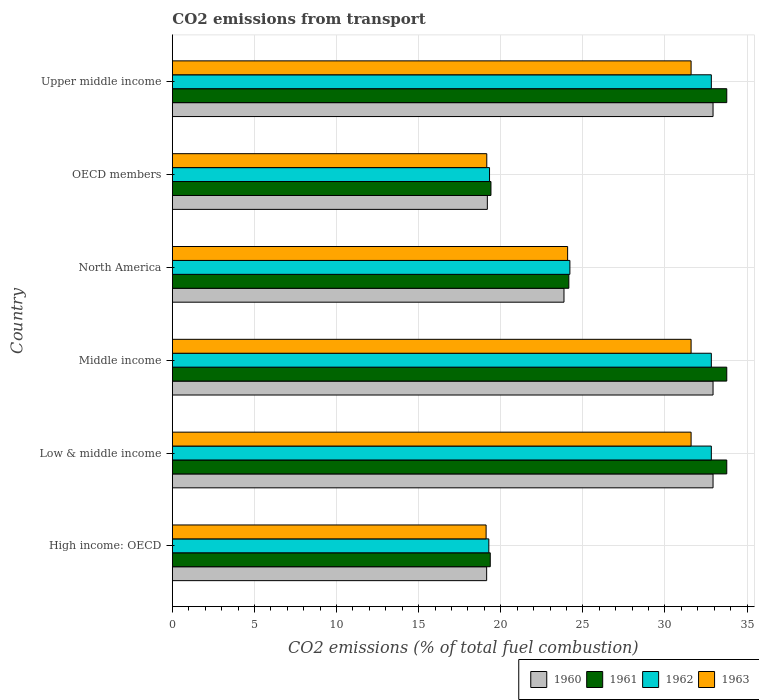How many different coloured bars are there?
Your response must be concise. 4. Are the number of bars per tick equal to the number of legend labels?
Your response must be concise. Yes. How many bars are there on the 2nd tick from the top?
Offer a terse response. 4. What is the label of the 2nd group of bars from the top?
Your answer should be very brief. OECD members. What is the total CO2 emitted in 1963 in North America?
Keep it short and to the point. 24.07. Across all countries, what is the maximum total CO2 emitted in 1963?
Offer a terse response. 31.59. Across all countries, what is the minimum total CO2 emitted in 1961?
Keep it short and to the point. 19.36. In which country was the total CO2 emitted in 1960 minimum?
Your answer should be very brief. High income: OECD. What is the total total CO2 emitted in 1962 in the graph?
Provide a short and direct response. 161.27. What is the difference between the total CO2 emitted in 1960 in North America and that in OECD members?
Ensure brevity in your answer.  4.67. What is the difference between the total CO2 emitted in 1961 in OECD members and the total CO2 emitted in 1963 in Upper middle income?
Keep it short and to the point. -12.19. What is the average total CO2 emitted in 1963 per country?
Give a very brief answer. 26.18. What is the difference between the total CO2 emitted in 1962 and total CO2 emitted in 1963 in Middle income?
Offer a terse response. 1.23. What is the ratio of the total CO2 emitted in 1963 in OECD members to that in Upper middle income?
Give a very brief answer. 0.61. Is the total CO2 emitted in 1962 in Low & middle income less than that in OECD members?
Give a very brief answer. No. What is the difference between the highest and the lowest total CO2 emitted in 1963?
Offer a very short reply. 12.48. How many bars are there?
Give a very brief answer. 24. How many countries are there in the graph?
Your answer should be compact. 6. What is the difference between two consecutive major ticks on the X-axis?
Offer a very short reply. 5. Are the values on the major ticks of X-axis written in scientific E-notation?
Offer a very short reply. No. Does the graph contain grids?
Your answer should be very brief. Yes. What is the title of the graph?
Make the answer very short. CO2 emissions from transport. What is the label or title of the X-axis?
Keep it short and to the point. CO2 emissions (% of total fuel combustion). What is the CO2 emissions (% of total fuel combustion) of 1960 in High income: OECD?
Offer a very short reply. 19.14. What is the CO2 emissions (% of total fuel combustion) of 1961 in High income: OECD?
Your response must be concise. 19.36. What is the CO2 emissions (% of total fuel combustion) of 1962 in High income: OECD?
Provide a succinct answer. 19.27. What is the CO2 emissions (% of total fuel combustion) in 1963 in High income: OECD?
Provide a short and direct response. 19.11. What is the CO2 emissions (% of total fuel combustion) of 1960 in Low & middle income?
Give a very brief answer. 32.93. What is the CO2 emissions (% of total fuel combustion) in 1961 in Low & middle income?
Keep it short and to the point. 33.76. What is the CO2 emissions (% of total fuel combustion) of 1962 in Low & middle income?
Give a very brief answer. 32.82. What is the CO2 emissions (% of total fuel combustion) in 1963 in Low & middle income?
Provide a short and direct response. 31.59. What is the CO2 emissions (% of total fuel combustion) in 1960 in Middle income?
Provide a succinct answer. 32.93. What is the CO2 emissions (% of total fuel combustion) of 1961 in Middle income?
Offer a very short reply. 33.76. What is the CO2 emissions (% of total fuel combustion) of 1962 in Middle income?
Provide a succinct answer. 32.82. What is the CO2 emissions (% of total fuel combustion) in 1963 in Middle income?
Your answer should be compact. 31.59. What is the CO2 emissions (% of total fuel combustion) of 1960 in North America?
Offer a very short reply. 23.85. What is the CO2 emissions (% of total fuel combustion) of 1961 in North America?
Ensure brevity in your answer.  24.15. What is the CO2 emissions (% of total fuel combustion) in 1962 in North America?
Ensure brevity in your answer.  24.21. What is the CO2 emissions (% of total fuel combustion) in 1963 in North America?
Offer a very short reply. 24.07. What is the CO2 emissions (% of total fuel combustion) of 1960 in OECD members?
Offer a terse response. 19.18. What is the CO2 emissions (% of total fuel combustion) in 1961 in OECD members?
Give a very brief answer. 19.4. What is the CO2 emissions (% of total fuel combustion) in 1962 in OECD members?
Your answer should be very brief. 19.32. What is the CO2 emissions (% of total fuel combustion) of 1963 in OECD members?
Provide a succinct answer. 19.15. What is the CO2 emissions (% of total fuel combustion) in 1960 in Upper middle income?
Make the answer very short. 32.93. What is the CO2 emissions (% of total fuel combustion) in 1961 in Upper middle income?
Keep it short and to the point. 33.76. What is the CO2 emissions (% of total fuel combustion) in 1962 in Upper middle income?
Your answer should be compact. 32.82. What is the CO2 emissions (% of total fuel combustion) in 1963 in Upper middle income?
Ensure brevity in your answer.  31.59. Across all countries, what is the maximum CO2 emissions (% of total fuel combustion) of 1960?
Ensure brevity in your answer.  32.93. Across all countries, what is the maximum CO2 emissions (% of total fuel combustion) of 1961?
Offer a terse response. 33.76. Across all countries, what is the maximum CO2 emissions (% of total fuel combustion) in 1962?
Provide a succinct answer. 32.82. Across all countries, what is the maximum CO2 emissions (% of total fuel combustion) of 1963?
Ensure brevity in your answer.  31.59. Across all countries, what is the minimum CO2 emissions (% of total fuel combustion) in 1960?
Your response must be concise. 19.14. Across all countries, what is the minimum CO2 emissions (% of total fuel combustion) in 1961?
Your answer should be compact. 19.36. Across all countries, what is the minimum CO2 emissions (% of total fuel combustion) of 1962?
Offer a very short reply. 19.27. Across all countries, what is the minimum CO2 emissions (% of total fuel combustion) of 1963?
Your answer should be compact. 19.11. What is the total CO2 emissions (% of total fuel combustion) of 1960 in the graph?
Ensure brevity in your answer.  160.96. What is the total CO2 emissions (% of total fuel combustion) in 1961 in the graph?
Your answer should be very brief. 164.2. What is the total CO2 emissions (% of total fuel combustion) in 1962 in the graph?
Ensure brevity in your answer.  161.27. What is the total CO2 emissions (% of total fuel combustion) in 1963 in the graph?
Provide a succinct answer. 157.1. What is the difference between the CO2 emissions (% of total fuel combustion) in 1960 in High income: OECD and that in Low & middle income?
Make the answer very short. -13.79. What is the difference between the CO2 emissions (% of total fuel combustion) in 1961 in High income: OECD and that in Low & middle income?
Ensure brevity in your answer.  -14.4. What is the difference between the CO2 emissions (% of total fuel combustion) in 1962 in High income: OECD and that in Low & middle income?
Give a very brief answer. -13.55. What is the difference between the CO2 emissions (% of total fuel combustion) in 1963 in High income: OECD and that in Low & middle income?
Keep it short and to the point. -12.48. What is the difference between the CO2 emissions (% of total fuel combustion) of 1960 in High income: OECD and that in Middle income?
Provide a succinct answer. -13.79. What is the difference between the CO2 emissions (% of total fuel combustion) of 1961 in High income: OECD and that in Middle income?
Provide a succinct answer. -14.4. What is the difference between the CO2 emissions (% of total fuel combustion) of 1962 in High income: OECD and that in Middle income?
Keep it short and to the point. -13.55. What is the difference between the CO2 emissions (% of total fuel combustion) of 1963 in High income: OECD and that in Middle income?
Make the answer very short. -12.48. What is the difference between the CO2 emissions (% of total fuel combustion) of 1960 in High income: OECD and that in North America?
Make the answer very short. -4.71. What is the difference between the CO2 emissions (% of total fuel combustion) of 1961 in High income: OECD and that in North America?
Offer a terse response. -4.79. What is the difference between the CO2 emissions (% of total fuel combustion) in 1962 in High income: OECD and that in North America?
Offer a very short reply. -4.94. What is the difference between the CO2 emissions (% of total fuel combustion) of 1963 in High income: OECD and that in North America?
Provide a succinct answer. -4.96. What is the difference between the CO2 emissions (% of total fuel combustion) of 1960 in High income: OECD and that in OECD members?
Offer a very short reply. -0.04. What is the difference between the CO2 emissions (% of total fuel combustion) of 1961 in High income: OECD and that in OECD members?
Your response must be concise. -0.04. What is the difference between the CO2 emissions (% of total fuel combustion) in 1962 in High income: OECD and that in OECD members?
Your answer should be compact. -0.04. What is the difference between the CO2 emissions (% of total fuel combustion) in 1963 in High income: OECD and that in OECD members?
Your answer should be compact. -0.04. What is the difference between the CO2 emissions (% of total fuel combustion) of 1960 in High income: OECD and that in Upper middle income?
Your response must be concise. -13.79. What is the difference between the CO2 emissions (% of total fuel combustion) in 1961 in High income: OECD and that in Upper middle income?
Offer a terse response. -14.4. What is the difference between the CO2 emissions (% of total fuel combustion) in 1962 in High income: OECD and that in Upper middle income?
Give a very brief answer. -13.55. What is the difference between the CO2 emissions (% of total fuel combustion) in 1963 in High income: OECD and that in Upper middle income?
Your answer should be compact. -12.48. What is the difference between the CO2 emissions (% of total fuel combustion) in 1962 in Low & middle income and that in Middle income?
Provide a short and direct response. 0. What is the difference between the CO2 emissions (% of total fuel combustion) of 1960 in Low & middle income and that in North America?
Offer a very short reply. 9.08. What is the difference between the CO2 emissions (% of total fuel combustion) in 1961 in Low & middle income and that in North America?
Provide a short and direct response. 9.62. What is the difference between the CO2 emissions (% of total fuel combustion) of 1962 in Low & middle income and that in North America?
Ensure brevity in your answer.  8.61. What is the difference between the CO2 emissions (% of total fuel combustion) in 1963 in Low & middle income and that in North America?
Provide a succinct answer. 7.52. What is the difference between the CO2 emissions (% of total fuel combustion) of 1960 in Low & middle income and that in OECD members?
Your response must be concise. 13.75. What is the difference between the CO2 emissions (% of total fuel combustion) in 1961 in Low & middle income and that in OECD members?
Ensure brevity in your answer.  14.36. What is the difference between the CO2 emissions (% of total fuel combustion) in 1962 in Low & middle income and that in OECD members?
Provide a short and direct response. 13.51. What is the difference between the CO2 emissions (% of total fuel combustion) in 1963 in Low & middle income and that in OECD members?
Offer a terse response. 12.44. What is the difference between the CO2 emissions (% of total fuel combustion) of 1960 in Low & middle income and that in Upper middle income?
Your answer should be very brief. 0. What is the difference between the CO2 emissions (% of total fuel combustion) of 1961 in Low & middle income and that in Upper middle income?
Keep it short and to the point. 0. What is the difference between the CO2 emissions (% of total fuel combustion) of 1963 in Low & middle income and that in Upper middle income?
Your answer should be very brief. 0. What is the difference between the CO2 emissions (% of total fuel combustion) in 1960 in Middle income and that in North America?
Give a very brief answer. 9.08. What is the difference between the CO2 emissions (% of total fuel combustion) of 1961 in Middle income and that in North America?
Provide a succinct answer. 9.62. What is the difference between the CO2 emissions (% of total fuel combustion) of 1962 in Middle income and that in North America?
Provide a short and direct response. 8.61. What is the difference between the CO2 emissions (% of total fuel combustion) of 1963 in Middle income and that in North America?
Your answer should be very brief. 7.52. What is the difference between the CO2 emissions (% of total fuel combustion) of 1960 in Middle income and that in OECD members?
Provide a short and direct response. 13.75. What is the difference between the CO2 emissions (% of total fuel combustion) in 1961 in Middle income and that in OECD members?
Offer a terse response. 14.36. What is the difference between the CO2 emissions (% of total fuel combustion) in 1962 in Middle income and that in OECD members?
Your answer should be very brief. 13.51. What is the difference between the CO2 emissions (% of total fuel combustion) in 1963 in Middle income and that in OECD members?
Give a very brief answer. 12.44. What is the difference between the CO2 emissions (% of total fuel combustion) in 1960 in Middle income and that in Upper middle income?
Provide a succinct answer. 0. What is the difference between the CO2 emissions (% of total fuel combustion) of 1961 in Middle income and that in Upper middle income?
Make the answer very short. 0. What is the difference between the CO2 emissions (% of total fuel combustion) in 1960 in North America and that in OECD members?
Give a very brief answer. 4.67. What is the difference between the CO2 emissions (% of total fuel combustion) of 1961 in North America and that in OECD members?
Offer a very short reply. 4.74. What is the difference between the CO2 emissions (% of total fuel combustion) in 1962 in North America and that in OECD members?
Give a very brief answer. 4.89. What is the difference between the CO2 emissions (% of total fuel combustion) of 1963 in North America and that in OECD members?
Provide a succinct answer. 4.92. What is the difference between the CO2 emissions (% of total fuel combustion) in 1960 in North America and that in Upper middle income?
Give a very brief answer. -9.08. What is the difference between the CO2 emissions (% of total fuel combustion) in 1961 in North America and that in Upper middle income?
Offer a very short reply. -9.62. What is the difference between the CO2 emissions (% of total fuel combustion) in 1962 in North America and that in Upper middle income?
Make the answer very short. -8.61. What is the difference between the CO2 emissions (% of total fuel combustion) of 1963 in North America and that in Upper middle income?
Ensure brevity in your answer.  -7.52. What is the difference between the CO2 emissions (% of total fuel combustion) of 1960 in OECD members and that in Upper middle income?
Provide a succinct answer. -13.75. What is the difference between the CO2 emissions (% of total fuel combustion) in 1961 in OECD members and that in Upper middle income?
Provide a short and direct response. -14.36. What is the difference between the CO2 emissions (% of total fuel combustion) in 1962 in OECD members and that in Upper middle income?
Make the answer very short. -13.51. What is the difference between the CO2 emissions (% of total fuel combustion) in 1963 in OECD members and that in Upper middle income?
Make the answer very short. -12.44. What is the difference between the CO2 emissions (% of total fuel combustion) in 1960 in High income: OECD and the CO2 emissions (% of total fuel combustion) in 1961 in Low & middle income?
Make the answer very short. -14.62. What is the difference between the CO2 emissions (% of total fuel combustion) of 1960 in High income: OECD and the CO2 emissions (% of total fuel combustion) of 1962 in Low & middle income?
Provide a succinct answer. -13.68. What is the difference between the CO2 emissions (% of total fuel combustion) in 1960 in High income: OECD and the CO2 emissions (% of total fuel combustion) in 1963 in Low & middle income?
Keep it short and to the point. -12.45. What is the difference between the CO2 emissions (% of total fuel combustion) in 1961 in High income: OECD and the CO2 emissions (% of total fuel combustion) in 1962 in Low & middle income?
Provide a short and direct response. -13.46. What is the difference between the CO2 emissions (% of total fuel combustion) in 1961 in High income: OECD and the CO2 emissions (% of total fuel combustion) in 1963 in Low & middle income?
Ensure brevity in your answer.  -12.23. What is the difference between the CO2 emissions (% of total fuel combustion) of 1962 in High income: OECD and the CO2 emissions (% of total fuel combustion) of 1963 in Low & middle income?
Offer a terse response. -12.32. What is the difference between the CO2 emissions (% of total fuel combustion) of 1960 in High income: OECD and the CO2 emissions (% of total fuel combustion) of 1961 in Middle income?
Offer a very short reply. -14.62. What is the difference between the CO2 emissions (% of total fuel combustion) of 1960 in High income: OECD and the CO2 emissions (% of total fuel combustion) of 1962 in Middle income?
Your answer should be very brief. -13.68. What is the difference between the CO2 emissions (% of total fuel combustion) of 1960 in High income: OECD and the CO2 emissions (% of total fuel combustion) of 1963 in Middle income?
Your response must be concise. -12.45. What is the difference between the CO2 emissions (% of total fuel combustion) of 1961 in High income: OECD and the CO2 emissions (% of total fuel combustion) of 1962 in Middle income?
Provide a succinct answer. -13.46. What is the difference between the CO2 emissions (% of total fuel combustion) in 1961 in High income: OECD and the CO2 emissions (% of total fuel combustion) in 1963 in Middle income?
Ensure brevity in your answer.  -12.23. What is the difference between the CO2 emissions (% of total fuel combustion) of 1962 in High income: OECD and the CO2 emissions (% of total fuel combustion) of 1963 in Middle income?
Ensure brevity in your answer.  -12.32. What is the difference between the CO2 emissions (% of total fuel combustion) of 1960 in High income: OECD and the CO2 emissions (% of total fuel combustion) of 1961 in North America?
Offer a very short reply. -5.01. What is the difference between the CO2 emissions (% of total fuel combustion) in 1960 in High income: OECD and the CO2 emissions (% of total fuel combustion) in 1962 in North America?
Your response must be concise. -5.07. What is the difference between the CO2 emissions (% of total fuel combustion) in 1960 in High income: OECD and the CO2 emissions (% of total fuel combustion) in 1963 in North America?
Your answer should be very brief. -4.93. What is the difference between the CO2 emissions (% of total fuel combustion) of 1961 in High income: OECD and the CO2 emissions (% of total fuel combustion) of 1962 in North America?
Your answer should be very brief. -4.85. What is the difference between the CO2 emissions (% of total fuel combustion) in 1961 in High income: OECD and the CO2 emissions (% of total fuel combustion) in 1963 in North America?
Make the answer very short. -4.71. What is the difference between the CO2 emissions (% of total fuel combustion) in 1962 in High income: OECD and the CO2 emissions (% of total fuel combustion) in 1963 in North America?
Your answer should be very brief. -4.8. What is the difference between the CO2 emissions (% of total fuel combustion) of 1960 in High income: OECD and the CO2 emissions (% of total fuel combustion) of 1961 in OECD members?
Your response must be concise. -0.26. What is the difference between the CO2 emissions (% of total fuel combustion) in 1960 in High income: OECD and the CO2 emissions (% of total fuel combustion) in 1962 in OECD members?
Your answer should be very brief. -0.18. What is the difference between the CO2 emissions (% of total fuel combustion) of 1960 in High income: OECD and the CO2 emissions (% of total fuel combustion) of 1963 in OECD members?
Provide a succinct answer. -0.01. What is the difference between the CO2 emissions (% of total fuel combustion) of 1961 in High income: OECD and the CO2 emissions (% of total fuel combustion) of 1962 in OECD members?
Provide a short and direct response. 0.04. What is the difference between the CO2 emissions (% of total fuel combustion) in 1961 in High income: OECD and the CO2 emissions (% of total fuel combustion) in 1963 in OECD members?
Your answer should be compact. 0.21. What is the difference between the CO2 emissions (% of total fuel combustion) in 1962 in High income: OECD and the CO2 emissions (% of total fuel combustion) in 1963 in OECD members?
Provide a short and direct response. 0.13. What is the difference between the CO2 emissions (% of total fuel combustion) in 1960 in High income: OECD and the CO2 emissions (% of total fuel combustion) in 1961 in Upper middle income?
Keep it short and to the point. -14.62. What is the difference between the CO2 emissions (% of total fuel combustion) of 1960 in High income: OECD and the CO2 emissions (% of total fuel combustion) of 1962 in Upper middle income?
Your answer should be compact. -13.68. What is the difference between the CO2 emissions (% of total fuel combustion) of 1960 in High income: OECD and the CO2 emissions (% of total fuel combustion) of 1963 in Upper middle income?
Keep it short and to the point. -12.45. What is the difference between the CO2 emissions (% of total fuel combustion) in 1961 in High income: OECD and the CO2 emissions (% of total fuel combustion) in 1962 in Upper middle income?
Ensure brevity in your answer.  -13.46. What is the difference between the CO2 emissions (% of total fuel combustion) in 1961 in High income: OECD and the CO2 emissions (% of total fuel combustion) in 1963 in Upper middle income?
Provide a succinct answer. -12.23. What is the difference between the CO2 emissions (% of total fuel combustion) in 1962 in High income: OECD and the CO2 emissions (% of total fuel combustion) in 1963 in Upper middle income?
Give a very brief answer. -12.32. What is the difference between the CO2 emissions (% of total fuel combustion) in 1960 in Low & middle income and the CO2 emissions (% of total fuel combustion) in 1961 in Middle income?
Ensure brevity in your answer.  -0.84. What is the difference between the CO2 emissions (% of total fuel combustion) in 1960 in Low & middle income and the CO2 emissions (% of total fuel combustion) in 1962 in Middle income?
Provide a succinct answer. 0.1. What is the difference between the CO2 emissions (% of total fuel combustion) in 1960 in Low & middle income and the CO2 emissions (% of total fuel combustion) in 1963 in Middle income?
Offer a very short reply. 1.34. What is the difference between the CO2 emissions (% of total fuel combustion) of 1961 in Low & middle income and the CO2 emissions (% of total fuel combustion) of 1962 in Middle income?
Provide a succinct answer. 0.94. What is the difference between the CO2 emissions (% of total fuel combustion) in 1961 in Low & middle income and the CO2 emissions (% of total fuel combustion) in 1963 in Middle income?
Provide a succinct answer. 2.17. What is the difference between the CO2 emissions (% of total fuel combustion) in 1962 in Low & middle income and the CO2 emissions (% of total fuel combustion) in 1963 in Middle income?
Your response must be concise. 1.23. What is the difference between the CO2 emissions (% of total fuel combustion) of 1960 in Low & middle income and the CO2 emissions (% of total fuel combustion) of 1961 in North America?
Ensure brevity in your answer.  8.78. What is the difference between the CO2 emissions (% of total fuel combustion) of 1960 in Low & middle income and the CO2 emissions (% of total fuel combustion) of 1962 in North America?
Your answer should be compact. 8.72. What is the difference between the CO2 emissions (% of total fuel combustion) in 1960 in Low & middle income and the CO2 emissions (% of total fuel combustion) in 1963 in North America?
Make the answer very short. 8.86. What is the difference between the CO2 emissions (% of total fuel combustion) in 1961 in Low & middle income and the CO2 emissions (% of total fuel combustion) in 1962 in North America?
Ensure brevity in your answer.  9.55. What is the difference between the CO2 emissions (% of total fuel combustion) of 1961 in Low & middle income and the CO2 emissions (% of total fuel combustion) of 1963 in North America?
Your response must be concise. 9.69. What is the difference between the CO2 emissions (% of total fuel combustion) in 1962 in Low & middle income and the CO2 emissions (% of total fuel combustion) in 1963 in North America?
Make the answer very short. 8.75. What is the difference between the CO2 emissions (% of total fuel combustion) of 1960 in Low & middle income and the CO2 emissions (% of total fuel combustion) of 1961 in OECD members?
Offer a very short reply. 13.53. What is the difference between the CO2 emissions (% of total fuel combustion) in 1960 in Low & middle income and the CO2 emissions (% of total fuel combustion) in 1962 in OECD members?
Offer a very short reply. 13.61. What is the difference between the CO2 emissions (% of total fuel combustion) of 1960 in Low & middle income and the CO2 emissions (% of total fuel combustion) of 1963 in OECD members?
Ensure brevity in your answer.  13.78. What is the difference between the CO2 emissions (% of total fuel combustion) in 1961 in Low & middle income and the CO2 emissions (% of total fuel combustion) in 1962 in OECD members?
Your answer should be very brief. 14.45. What is the difference between the CO2 emissions (% of total fuel combustion) of 1961 in Low & middle income and the CO2 emissions (% of total fuel combustion) of 1963 in OECD members?
Provide a short and direct response. 14.62. What is the difference between the CO2 emissions (% of total fuel combustion) of 1962 in Low & middle income and the CO2 emissions (% of total fuel combustion) of 1963 in OECD members?
Ensure brevity in your answer.  13.68. What is the difference between the CO2 emissions (% of total fuel combustion) in 1960 in Low & middle income and the CO2 emissions (% of total fuel combustion) in 1961 in Upper middle income?
Make the answer very short. -0.84. What is the difference between the CO2 emissions (% of total fuel combustion) of 1960 in Low & middle income and the CO2 emissions (% of total fuel combustion) of 1962 in Upper middle income?
Your answer should be very brief. 0.1. What is the difference between the CO2 emissions (% of total fuel combustion) of 1960 in Low & middle income and the CO2 emissions (% of total fuel combustion) of 1963 in Upper middle income?
Provide a short and direct response. 1.34. What is the difference between the CO2 emissions (% of total fuel combustion) of 1961 in Low & middle income and the CO2 emissions (% of total fuel combustion) of 1962 in Upper middle income?
Offer a terse response. 0.94. What is the difference between the CO2 emissions (% of total fuel combustion) in 1961 in Low & middle income and the CO2 emissions (% of total fuel combustion) in 1963 in Upper middle income?
Your answer should be compact. 2.17. What is the difference between the CO2 emissions (% of total fuel combustion) of 1962 in Low & middle income and the CO2 emissions (% of total fuel combustion) of 1963 in Upper middle income?
Offer a terse response. 1.23. What is the difference between the CO2 emissions (% of total fuel combustion) in 1960 in Middle income and the CO2 emissions (% of total fuel combustion) in 1961 in North America?
Ensure brevity in your answer.  8.78. What is the difference between the CO2 emissions (% of total fuel combustion) in 1960 in Middle income and the CO2 emissions (% of total fuel combustion) in 1962 in North America?
Make the answer very short. 8.72. What is the difference between the CO2 emissions (% of total fuel combustion) of 1960 in Middle income and the CO2 emissions (% of total fuel combustion) of 1963 in North America?
Keep it short and to the point. 8.86. What is the difference between the CO2 emissions (% of total fuel combustion) of 1961 in Middle income and the CO2 emissions (% of total fuel combustion) of 1962 in North America?
Offer a very short reply. 9.55. What is the difference between the CO2 emissions (% of total fuel combustion) of 1961 in Middle income and the CO2 emissions (% of total fuel combustion) of 1963 in North America?
Offer a very short reply. 9.69. What is the difference between the CO2 emissions (% of total fuel combustion) of 1962 in Middle income and the CO2 emissions (% of total fuel combustion) of 1963 in North America?
Your response must be concise. 8.75. What is the difference between the CO2 emissions (% of total fuel combustion) of 1960 in Middle income and the CO2 emissions (% of total fuel combustion) of 1961 in OECD members?
Your response must be concise. 13.53. What is the difference between the CO2 emissions (% of total fuel combustion) in 1960 in Middle income and the CO2 emissions (% of total fuel combustion) in 1962 in OECD members?
Provide a succinct answer. 13.61. What is the difference between the CO2 emissions (% of total fuel combustion) of 1960 in Middle income and the CO2 emissions (% of total fuel combustion) of 1963 in OECD members?
Your answer should be very brief. 13.78. What is the difference between the CO2 emissions (% of total fuel combustion) of 1961 in Middle income and the CO2 emissions (% of total fuel combustion) of 1962 in OECD members?
Provide a short and direct response. 14.45. What is the difference between the CO2 emissions (% of total fuel combustion) in 1961 in Middle income and the CO2 emissions (% of total fuel combustion) in 1963 in OECD members?
Offer a very short reply. 14.62. What is the difference between the CO2 emissions (% of total fuel combustion) in 1962 in Middle income and the CO2 emissions (% of total fuel combustion) in 1963 in OECD members?
Offer a very short reply. 13.68. What is the difference between the CO2 emissions (% of total fuel combustion) of 1960 in Middle income and the CO2 emissions (% of total fuel combustion) of 1961 in Upper middle income?
Provide a short and direct response. -0.84. What is the difference between the CO2 emissions (% of total fuel combustion) of 1960 in Middle income and the CO2 emissions (% of total fuel combustion) of 1962 in Upper middle income?
Give a very brief answer. 0.1. What is the difference between the CO2 emissions (% of total fuel combustion) of 1960 in Middle income and the CO2 emissions (% of total fuel combustion) of 1963 in Upper middle income?
Provide a short and direct response. 1.34. What is the difference between the CO2 emissions (% of total fuel combustion) of 1961 in Middle income and the CO2 emissions (% of total fuel combustion) of 1962 in Upper middle income?
Make the answer very short. 0.94. What is the difference between the CO2 emissions (% of total fuel combustion) of 1961 in Middle income and the CO2 emissions (% of total fuel combustion) of 1963 in Upper middle income?
Offer a very short reply. 2.17. What is the difference between the CO2 emissions (% of total fuel combustion) in 1962 in Middle income and the CO2 emissions (% of total fuel combustion) in 1963 in Upper middle income?
Your answer should be compact. 1.23. What is the difference between the CO2 emissions (% of total fuel combustion) in 1960 in North America and the CO2 emissions (% of total fuel combustion) in 1961 in OECD members?
Ensure brevity in your answer.  4.45. What is the difference between the CO2 emissions (% of total fuel combustion) of 1960 in North America and the CO2 emissions (% of total fuel combustion) of 1962 in OECD members?
Keep it short and to the point. 4.53. What is the difference between the CO2 emissions (% of total fuel combustion) in 1960 in North America and the CO2 emissions (% of total fuel combustion) in 1963 in OECD members?
Ensure brevity in your answer.  4.7. What is the difference between the CO2 emissions (% of total fuel combustion) in 1961 in North America and the CO2 emissions (% of total fuel combustion) in 1962 in OECD members?
Keep it short and to the point. 4.83. What is the difference between the CO2 emissions (% of total fuel combustion) of 1961 in North America and the CO2 emissions (% of total fuel combustion) of 1963 in OECD members?
Your answer should be very brief. 5. What is the difference between the CO2 emissions (% of total fuel combustion) of 1962 in North America and the CO2 emissions (% of total fuel combustion) of 1963 in OECD members?
Provide a short and direct response. 5.06. What is the difference between the CO2 emissions (% of total fuel combustion) of 1960 in North America and the CO2 emissions (% of total fuel combustion) of 1961 in Upper middle income?
Provide a short and direct response. -9.91. What is the difference between the CO2 emissions (% of total fuel combustion) in 1960 in North America and the CO2 emissions (% of total fuel combustion) in 1962 in Upper middle income?
Your answer should be compact. -8.97. What is the difference between the CO2 emissions (% of total fuel combustion) of 1960 in North America and the CO2 emissions (% of total fuel combustion) of 1963 in Upper middle income?
Your answer should be compact. -7.74. What is the difference between the CO2 emissions (% of total fuel combustion) of 1961 in North America and the CO2 emissions (% of total fuel combustion) of 1962 in Upper middle income?
Provide a succinct answer. -8.68. What is the difference between the CO2 emissions (% of total fuel combustion) in 1961 in North America and the CO2 emissions (% of total fuel combustion) in 1963 in Upper middle income?
Give a very brief answer. -7.45. What is the difference between the CO2 emissions (% of total fuel combustion) of 1962 in North America and the CO2 emissions (% of total fuel combustion) of 1963 in Upper middle income?
Provide a short and direct response. -7.38. What is the difference between the CO2 emissions (% of total fuel combustion) of 1960 in OECD members and the CO2 emissions (% of total fuel combustion) of 1961 in Upper middle income?
Provide a short and direct response. -14.58. What is the difference between the CO2 emissions (% of total fuel combustion) of 1960 in OECD members and the CO2 emissions (% of total fuel combustion) of 1962 in Upper middle income?
Make the answer very short. -13.64. What is the difference between the CO2 emissions (% of total fuel combustion) in 1960 in OECD members and the CO2 emissions (% of total fuel combustion) in 1963 in Upper middle income?
Offer a very short reply. -12.41. What is the difference between the CO2 emissions (% of total fuel combustion) in 1961 in OECD members and the CO2 emissions (% of total fuel combustion) in 1962 in Upper middle income?
Your answer should be very brief. -13.42. What is the difference between the CO2 emissions (% of total fuel combustion) of 1961 in OECD members and the CO2 emissions (% of total fuel combustion) of 1963 in Upper middle income?
Provide a succinct answer. -12.19. What is the difference between the CO2 emissions (% of total fuel combustion) in 1962 in OECD members and the CO2 emissions (% of total fuel combustion) in 1963 in Upper middle income?
Offer a very short reply. -12.28. What is the average CO2 emissions (% of total fuel combustion) in 1960 per country?
Your response must be concise. 26.83. What is the average CO2 emissions (% of total fuel combustion) of 1961 per country?
Keep it short and to the point. 27.37. What is the average CO2 emissions (% of total fuel combustion) of 1962 per country?
Ensure brevity in your answer.  26.88. What is the average CO2 emissions (% of total fuel combustion) of 1963 per country?
Give a very brief answer. 26.18. What is the difference between the CO2 emissions (% of total fuel combustion) in 1960 and CO2 emissions (% of total fuel combustion) in 1961 in High income: OECD?
Provide a succinct answer. -0.22. What is the difference between the CO2 emissions (% of total fuel combustion) of 1960 and CO2 emissions (% of total fuel combustion) of 1962 in High income: OECD?
Make the answer very short. -0.13. What is the difference between the CO2 emissions (% of total fuel combustion) of 1960 and CO2 emissions (% of total fuel combustion) of 1963 in High income: OECD?
Your response must be concise. 0.03. What is the difference between the CO2 emissions (% of total fuel combustion) in 1961 and CO2 emissions (% of total fuel combustion) in 1962 in High income: OECD?
Provide a short and direct response. 0.09. What is the difference between the CO2 emissions (% of total fuel combustion) in 1961 and CO2 emissions (% of total fuel combustion) in 1963 in High income: OECD?
Provide a short and direct response. 0.25. What is the difference between the CO2 emissions (% of total fuel combustion) of 1962 and CO2 emissions (% of total fuel combustion) of 1963 in High income: OECD?
Offer a very short reply. 0.17. What is the difference between the CO2 emissions (% of total fuel combustion) in 1960 and CO2 emissions (% of total fuel combustion) in 1961 in Low & middle income?
Give a very brief answer. -0.84. What is the difference between the CO2 emissions (% of total fuel combustion) in 1960 and CO2 emissions (% of total fuel combustion) in 1962 in Low & middle income?
Give a very brief answer. 0.1. What is the difference between the CO2 emissions (% of total fuel combustion) in 1960 and CO2 emissions (% of total fuel combustion) in 1963 in Low & middle income?
Your response must be concise. 1.34. What is the difference between the CO2 emissions (% of total fuel combustion) in 1961 and CO2 emissions (% of total fuel combustion) in 1962 in Low & middle income?
Make the answer very short. 0.94. What is the difference between the CO2 emissions (% of total fuel combustion) of 1961 and CO2 emissions (% of total fuel combustion) of 1963 in Low & middle income?
Give a very brief answer. 2.17. What is the difference between the CO2 emissions (% of total fuel combustion) in 1962 and CO2 emissions (% of total fuel combustion) in 1963 in Low & middle income?
Make the answer very short. 1.23. What is the difference between the CO2 emissions (% of total fuel combustion) of 1960 and CO2 emissions (% of total fuel combustion) of 1961 in Middle income?
Ensure brevity in your answer.  -0.84. What is the difference between the CO2 emissions (% of total fuel combustion) of 1960 and CO2 emissions (% of total fuel combustion) of 1962 in Middle income?
Offer a terse response. 0.1. What is the difference between the CO2 emissions (% of total fuel combustion) in 1960 and CO2 emissions (% of total fuel combustion) in 1963 in Middle income?
Offer a terse response. 1.34. What is the difference between the CO2 emissions (% of total fuel combustion) in 1961 and CO2 emissions (% of total fuel combustion) in 1962 in Middle income?
Your response must be concise. 0.94. What is the difference between the CO2 emissions (% of total fuel combustion) of 1961 and CO2 emissions (% of total fuel combustion) of 1963 in Middle income?
Give a very brief answer. 2.17. What is the difference between the CO2 emissions (% of total fuel combustion) in 1962 and CO2 emissions (% of total fuel combustion) in 1963 in Middle income?
Give a very brief answer. 1.23. What is the difference between the CO2 emissions (% of total fuel combustion) of 1960 and CO2 emissions (% of total fuel combustion) of 1961 in North America?
Keep it short and to the point. -0.3. What is the difference between the CO2 emissions (% of total fuel combustion) in 1960 and CO2 emissions (% of total fuel combustion) in 1962 in North America?
Provide a succinct answer. -0.36. What is the difference between the CO2 emissions (% of total fuel combustion) of 1960 and CO2 emissions (% of total fuel combustion) of 1963 in North America?
Provide a short and direct response. -0.22. What is the difference between the CO2 emissions (% of total fuel combustion) in 1961 and CO2 emissions (% of total fuel combustion) in 1962 in North America?
Provide a short and direct response. -0.06. What is the difference between the CO2 emissions (% of total fuel combustion) in 1961 and CO2 emissions (% of total fuel combustion) in 1963 in North America?
Give a very brief answer. 0.07. What is the difference between the CO2 emissions (% of total fuel combustion) of 1962 and CO2 emissions (% of total fuel combustion) of 1963 in North America?
Give a very brief answer. 0.14. What is the difference between the CO2 emissions (% of total fuel combustion) in 1960 and CO2 emissions (% of total fuel combustion) in 1961 in OECD members?
Your answer should be compact. -0.22. What is the difference between the CO2 emissions (% of total fuel combustion) in 1960 and CO2 emissions (% of total fuel combustion) in 1962 in OECD members?
Your answer should be compact. -0.13. What is the difference between the CO2 emissions (% of total fuel combustion) in 1960 and CO2 emissions (% of total fuel combustion) in 1963 in OECD members?
Your answer should be very brief. 0.03. What is the difference between the CO2 emissions (% of total fuel combustion) of 1961 and CO2 emissions (% of total fuel combustion) of 1962 in OECD members?
Your answer should be very brief. 0.09. What is the difference between the CO2 emissions (% of total fuel combustion) in 1961 and CO2 emissions (% of total fuel combustion) in 1963 in OECD members?
Make the answer very short. 0.25. What is the difference between the CO2 emissions (% of total fuel combustion) in 1962 and CO2 emissions (% of total fuel combustion) in 1963 in OECD members?
Your answer should be compact. 0.17. What is the difference between the CO2 emissions (% of total fuel combustion) of 1960 and CO2 emissions (% of total fuel combustion) of 1961 in Upper middle income?
Make the answer very short. -0.84. What is the difference between the CO2 emissions (% of total fuel combustion) in 1960 and CO2 emissions (% of total fuel combustion) in 1962 in Upper middle income?
Ensure brevity in your answer.  0.1. What is the difference between the CO2 emissions (% of total fuel combustion) in 1960 and CO2 emissions (% of total fuel combustion) in 1963 in Upper middle income?
Your answer should be compact. 1.34. What is the difference between the CO2 emissions (% of total fuel combustion) in 1961 and CO2 emissions (% of total fuel combustion) in 1962 in Upper middle income?
Your answer should be compact. 0.94. What is the difference between the CO2 emissions (% of total fuel combustion) in 1961 and CO2 emissions (% of total fuel combustion) in 1963 in Upper middle income?
Provide a succinct answer. 2.17. What is the difference between the CO2 emissions (% of total fuel combustion) in 1962 and CO2 emissions (% of total fuel combustion) in 1963 in Upper middle income?
Your response must be concise. 1.23. What is the ratio of the CO2 emissions (% of total fuel combustion) in 1960 in High income: OECD to that in Low & middle income?
Your answer should be very brief. 0.58. What is the ratio of the CO2 emissions (% of total fuel combustion) of 1961 in High income: OECD to that in Low & middle income?
Offer a very short reply. 0.57. What is the ratio of the CO2 emissions (% of total fuel combustion) of 1962 in High income: OECD to that in Low & middle income?
Offer a very short reply. 0.59. What is the ratio of the CO2 emissions (% of total fuel combustion) in 1963 in High income: OECD to that in Low & middle income?
Your response must be concise. 0.6. What is the ratio of the CO2 emissions (% of total fuel combustion) in 1960 in High income: OECD to that in Middle income?
Provide a succinct answer. 0.58. What is the ratio of the CO2 emissions (% of total fuel combustion) of 1961 in High income: OECD to that in Middle income?
Offer a terse response. 0.57. What is the ratio of the CO2 emissions (% of total fuel combustion) in 1962 in High income: OECD to that in Middle income?
Your answer should be compact. 0.59. What is the ratio of the CO2 emissions (% of total fuel combustion) in 1963 in High income: OECD to that in Middle income?
Your response must be concise. 0.6. What is the ratio of the CO2 emissions (% of total fuel combustion) in 1960 in High income: OECD to that in North America?
Ensure brevity in your answer.  0.8. What is the ratio of the CO2 emissions (% of total fuel combustion) of 1961 in High income: OECD to that in North America?
Keep it short and to the point. 0.8. What is the ratio of the CO2 emissions (% of total fuel combustion) in 1962 in High income: OECD to that in North America?
Offer a terse response. 0.8. What is the ratio of the CO2 emissions (% of total fuel combustion) of 1963 in High income: OECD to that in North America?
Ensure brevity in your answer.  0.79. What is the ratio of the CO2 emissions (% of total fuel combustion) of 1961 in High income: OECD to that in OECD members?
Give a very brief answer. 1. What is the ratio of the CO2 emissions (% of total fuel combustion) in 1960 in High income: OECD to that in Upper middle income?
Give a very brief answer. 0.58. What is the ratio of the CO2 emissions (% of total fuel combustion) of 1961 in High income: OECD to that in Upper middle income?
Your response must be concise. 0.57. What is the ratio of the CO2 emissions (% of total fuel combustion) in 1962 in High income: OECD to that in Upper middle income?
Your answer should be very brief. 0.59. What is the ratio of the CO2 emissions (% of total fuel combustion) of 1963 in High income: OECD to that in Upper middle income?
Your answer should be very brief. 0.6. What is the ratio of the CO2 emissions (% of total fuel combustion) in 1960 in Low & middle income to that in North America?
Ensure brevity in your answer.  1.38. What is the ratio of the CO2 emissions (% of total fuel combustion) of 1961 in Low & middle income to that in North America?
Your answer should be compact. 1.4. What is the ratio of the CO2 emissions (% of total fuel combustion) in 1962 in Low & middle income to that in North America?
Give a very brief answer. 1.36. What is the ratio of the CO2 emissions (% of total fuel combustion) in 1963 in Low & middle income to that in North America?
Provide a short and direct response. 1.31. What is the ratio of the CO2 emissions (% of total fuel combustion) of 1960 in Low & middle income to that in OECD members?
Ensure brevity in your answer.  1.72. What is the ratio of the CO2 emissions (% of total fuel combustion) of 1961 in Low & middle income to that in OECD members?
Your response must be concise. 1.74. What is the ratio of the CO2 emissions (% of total fuel combustion) of 1962 in Low & middle income to that in OECD members?
Provide a succinct answer. 1.7. What is the ratio of the CO2 emissions (% of total fuel combustion) of 1963 in Low & middle income to that in OECD members?
Your response must be concise. 1.65. What is the ratio of the CO2 emissions (% of total fuel combustion) of 1960 in Low & middle income to that in Upper middle income?
Your answer should be compact. 1. What is the ratio of the CO2 emissions (% of total fuel combustion) in 1961 in Low & middle income to that in Upper middle income?
Your response must be concise. 1. What is the ratio of the CO2 emissions (% of total fuel combustion) of 1962 in Low & middle income to that in Upper middle income?
Provide a succinct answer. 1. What is the ratio of the CO2 emissions (% of total fuel combustion) in 1963 in Low & middle income to that in Upper middle income?
Your answer should be very brief. 1. What is the ratio of the CO2 emissions (% of total fuel combustion) of 1960 in Middle income to that in North America?
Your answer should be very brief. 1.38. What is the ratio of the CO2 emissions (% of total fuel combustion) of 1961 in Middle income to that in North America?
Your answer should be very brief. 1.4. What is the ratio of the CO2 emissions (% of total fuel combustion) of 1962 in Middle income to that in North America?
Your answer should be very brief. 1.36. What is the ratio of the CO2 emissions (% of total fuel combustion) in 1963 in Middle income to that in North America?
Make the answer very short. 1.31. What is the ratio of the CO2 emissions (% of total fuel combustion) in 1960 in Middle income to that in OECD members?
Keep it short and to the point. 1.72. What is the ratio of the CO2 emissions (% of total fuel combustion) in 1961 in Middle income to that in OECD members?
Keep it short and to the point. 1.74. What is the ratio of the CO2 emissions (% of total fuel combustion) in 1962 in Middle income to that in OECD members?
Keep it short and to the point. 1.7. What is the ratio of the CO2 emissions (% of total fuel combustion) in 1963 in Middle income to that in OECD members?
Your answer should be very brief. 1.65. What is the ratio of the CO2 emissions (% of total fuel combustion) in 1960 in Middle income to that in Upper middle income?
Give a very brief answer. 1. What is the ratio of the CO2 emissions (% of total fuel combustion) in 1962 in Middle income to that in Upper middle income?
Offer a terse response. 1. What is the ratio of the CO2 emissions (% of total fuel combustion) of 1963 in Middle income to that in Upper middle income?
Provide a succinct answer. 1. What is the ratio of the CO2 emissions (% of total fuel combustion) of 1960 in North America to that in OECD members?
Keep it short and to the point. 1.24. What is the ratio of the CO2 emissions (% of total fuel combustion) of 1961 in North America to that in OECD members?
Make the answer very short. 1.24. What is the ratio of the CO2 emissions (% of total fuel combustion) of 1962 in North America to that in OECD members?
Provide a short and direct response. 1.25. What is the ratio of the CO2 emissions (% of total fuel combustion) in 1963 in North America to that in OECD members?
Give a very brief answer. 1.26. What is the ratio of the CO2 emissions (% of total fuel combustion) of 1960 in North America to that in Upper middle income?
Your answer should be compact. 0.72. What is the ratio of the CO2 emissions (% of total fuel combustion) in 1961 in North America to that in Upper middle income?
Ensure brevity in your answer.  0.72. What is the ratio of the CO2 emissions (% of total fuel combustion) in 1962 in North America to that in Upper middle income?
Your answer should be very brief. 0.74. What is the ratio of the CO2 emissions (% of total fuel combustion) of 1963 in North America to that in Upper middle income?
Your answer should be compact. 0.76. What is the ratio of the CO2 emissions (% of total fuel combustion) of 1960 in OECD members to that in Upper middle income?
Your response must be concise. 0.58. What is the ratio of the CO2 emissions (% of total fuel combustion) of 1961 in OECD members to that in Upper middle income?
Provide a short and direct response. 0.57. What is the ratio of the CO2 emissions (% of total fuel combustion) in 1962 in OECD members to that in Upper middle income?
Provide a short and direct response. 0.59. What is the ratio of the CO2 emissions (% of total fuel combustion) of 1963 in OECD members to that in Upper middle income?
Provide a short and direct response. 0.61. What is the difference between the highest and the second highest CO2 emissions (% of total fuel combustion) of 1961?
Give a very brief answer. 0. What is the difference between the highest and the second highest CO2 emissions (% of total fuel combustion) in 1963?
Offer a terse response. 0. What is the difference between the highest and the lowest CO2 emissions (% of total fuel combustion) in 1960?
Provide a succinct answer. 13.79. What is the difference between the highest and the lowest CO2 emissions (% of total fuel combustion) of 1961?
Keep it short and to the point. 14.4. What is the difference between the highest and the lowest CO2 emissions (% of total fuel combustion) of 1962?
Your answer should be compact. 13.55. What is the difference between the highest and the lowest CO2 emissions (% of total fuel combustion) of 1963?
Your response must be concise. 12.48. 